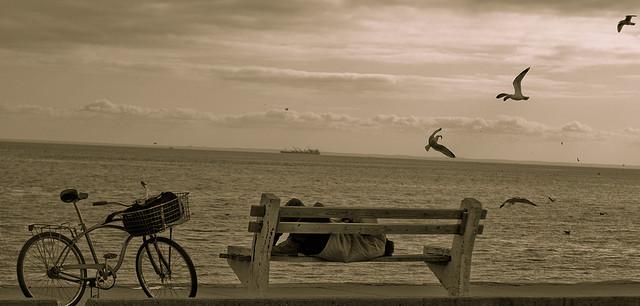What is in the basket on the bicycle?
Quick response, please. Bag. What kind of birds are those?
Write a very short answer. Seagulls. What holds the boards together?
Write a very short answer. Nails. What is in the sky?
Write a very short answer. Birds. What are flying?
Write a very short answer. Birds. Where us the bench?
Keep it brief. Beach. What is parked by the bench?
Answer briefly. Bike. How many birds are in the picture?
Be succinct. 4. How many bikes are in this scene?
Give a very brief answer. 1. What is sitting on the chair?
Keep it brief. Person. What is the person laying on?
Answer briefly. Bench. How many birds are there?
Write a very short answer. 4. Where is the bench?
Keep it brief. Beach. 